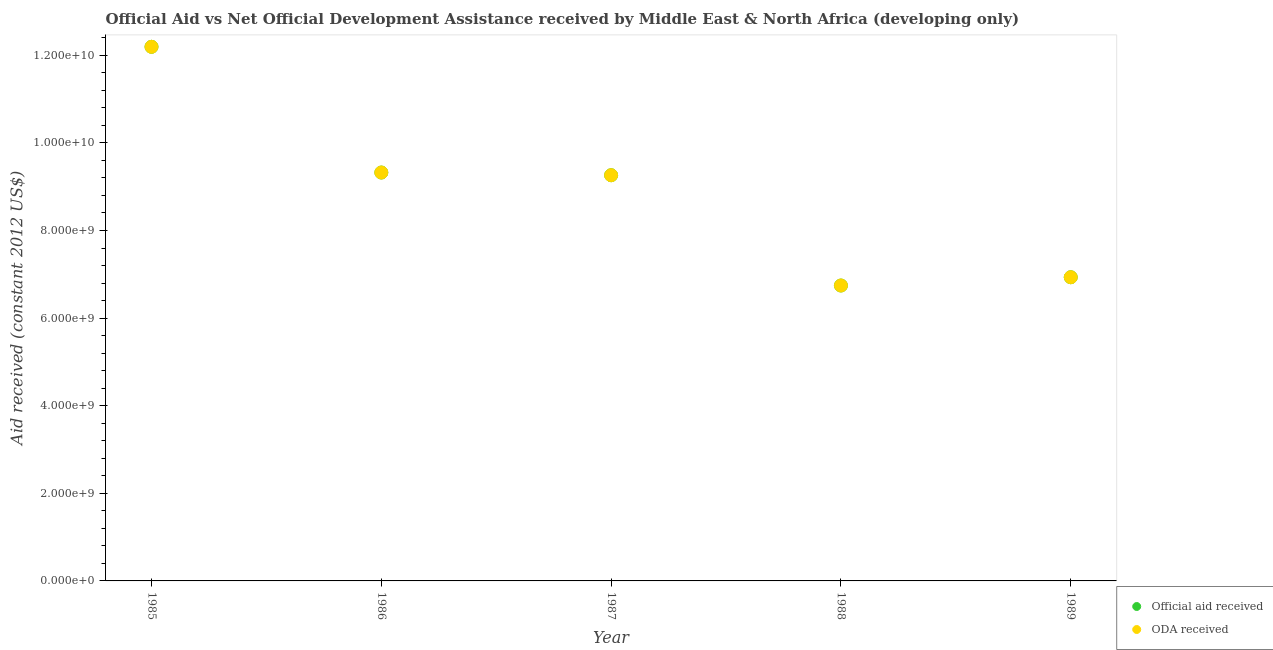How many different coloured dotlines are there?
Your answer should be compact. 2. Is the number of dotlines equal to the number of legend labels?
Your response must be concise. Yes. What is the oda received in 1987?
Your answer should be very brief. 9.26e+09. Across all years, what is the maximum oda received?
Offer a very short reply. 1.22e+1. Across all years, what is the minimum official aid received?
Offer a terse response. 6.74e+09. In which year was the official aid received maximum?
Give a very brief answer. 1985. What is the total oda received in the graph?
Offer a terse response. 4.45e+1. What is the difference between the oda received in 1986 and that in 1988?
Provide a short and direct response. 2.58e+09. What is the difference between the oda received in 1988 and the official aid received in 1986?
Ensure brevity in your answer.  -2.58e+09. What is the average oda received per year?
Keep it short and to the point. 8.89e+09. In the year 1988, what is the difference between the oda received and official aid received?
Your answer should be very brief. 0. In how many years, is the official aid received greater than 400000000 US$?
Give a very brief answer. 5. What is the ratio of the oda received in 1985 to that in 1987?
Ensure brevity in your answer.  1.32. What is the difference between the highest and the second highest oda received?
Provide a succinct answer. 2.87e+09. What is the difference between the highest and the lowest oda received?
Give a very brief answer. 5.45e+09. In how many years, is the official aid received greater than the average official aid received taken over all years?
Your answer should be compact. 3. Does the oda received monotonically increase over the years?
Make the answer very short. No. Is the oda received strictly less than the official aid received over the years?
Your answer should be very brief. No. How many dotlines are there?
Your response must be concise. 2. Are the values on the major ticks of Y-axis written in scientific E-notation?
Offer a very short reply. Yes. Where does the legend appear in the graph?
Your response must be concise. Bottom right. How are the legend labels stacked?
Give a very brief answer. Vertical. What is the title of the graph?
Ensure brevity in your answer.  Official Aid vs Net Official Development Assistance received by Middle East & North Africa (developing only) . Does "From production" appear as one of the legend labels in the graph?
Keep it short and to the point. No. What is the label or title of the X-axis?
Your answer should be compact. Year. What is the label or title of the Y-axis?
Your response must be concise. Aid received (constant 2012 US$). What is the Aid received (constant 2012 US$) in Official aid received in 1985?
Give a very brief answer. 1.22e+1. What is the Aid received (constant 2012 US$) in ODA received in 1985?
Provide a short and direct response. 1.22e+1. What is the Aid received (constant 2012 US$) in Official aid received in 1986?
Offer a terse response. 9.32e+09. What is the Aid received (constant 2012 US$) of ODA received in 1986?
Your answer should be compact. 9.32e+09. What is the Aid received (constant 2012 US$) in Official aid received in 1987?
Offer a terse response. 9.26e+09. What is the Aid received (constant 2012 US$) in ODA received in 1987?
Offer a terse response. 9.26e+09. What is the Aid received (constant 2012 US$) of Official aid received in 1988?
Provide a short and direct response. 6.74e+09. What is the Aid received (constant 2012 US$) of ODA received in 1988?
Give a very brief answer. 6.74e+09. What is the Aid received (constant 2012 US$) of Official aid received in 1989?
Provide a succinct answer. 6.93e+09. What is the Aid received (constant 2012 US$) in ODA received in 1989?
Make the answer very short. 6.93e+09. Across all years, what is the maximum Aid received (constant 2012 US$) in Official aid received?
Give a very brief answer. 1.22e+1. Across all years, what is the maximum Aid received (constant 2012 US$) of ODA received?
Give a very brief answer. 1.22e+1. Across all years, what is the minimum Aid received (constant 2012 US$) of Official aid received?
Ensure brevity in your answer.  6.74e+09. Across all years, what is the minimum Aid received (constant 2012 US$) of ODA received?
Your answer should be compact. 6.74e+09. What is the total Aid received (constant 2012 US$) in Official aid received in the graph?
Offer a terse response. 4.45e+1. What is the total Aid received (constant 2012 US$) of ODA received in the graph?
Keep it short and to the point. 4.45e+1. What is the difference between the Aid received (constant 2012 US$) of Official aid received in 1985 and that in 1986?
Offer a terse response. 2.87e+09. What is the difference between the Aid received (constant 2012 US$) of ODA received in 1985 and that in 1986?
Your answer should be very brief. 2.87e+09. What is the difference between the Aid received (constant 2012 US$) of Official aid received in 1985 and that in 1987?
Ensure brevity in your answer.  2.93e+09. What is the difference between the Aid received (constant 2012 US$) of ODA received in 1985 and that in 1987?
Your response must be concise. 2.93e+09. What is the difference between the Aid received (constant 2012 US$) of Official aid received in 1985 and that in 1988?
Ensure brevity in your answer.  5.45e+09. What is the difference between the Aid received (constant 2012 US$) in ODA received in 1985 and that in 1988?
Make the answer very short. 5.45e+09. What is the difference between the Aid received (constant 2012 US$) in Official aid received in 1985 and that in 1989?
Your answer should be compact. 5.26e+09. What is the difference between the Aid received (constant 2012 US$) in ODA received in 1985 and that in 1989?
Offer a terse response. 5.26e+09. What is the difference between the Aid received (constant 2012 US$) in Official aid received in 1986 and that in 1987?
Offer a terse response. 6.17e+07. What is the difference between the Aid received (constant 2012 US$) of ODA received in 1986 and that in 1987?
Provide a short and direct response. 6.17e+07. What is the difference between the Aid received (constant 2012 US$) in Official aid received in 1986 and that in 1988?
Provide a short and direct response. 2.58e+09. What is the difference between the Aid received (constant 2012 US$) of ODA received in 1986 and that in 1988?
Your response must be concise. 2.58e+09. What is the difference between the Aid received (constant 2012 US$) in Official aid received in 1986 and that in 1989?
Your response must be concise. 2.39e+09. What is the difference between the Aid received (constant 2012 US$) in ODA received in 1986 and that in 1989?
Keep it short and to the point. 2.39e+09. What is the difference between the Aid received (constant 2012 US$) of Official aid received in 1987 and that in 1988?
Keep it short and to the point. 2.52e+09. What is the difference between the Aid received (constant 2012 US$) of ODA received in 1987 and that in 1988?
Offer a terse response. 2.52e+09. What is the difference between the Aid received (constant 2012 US$) in Official aid received in 1987 and that in 1989?
Your answer should be compact. 2.33e+09. What is the difference between the Aid received (constant 2012 US$) of ODA received in 1987 and that in 1989?
Give a very brief answer. 2.33e+09. What is the difference between the Aid received (constant 2012 US$) in Official aid received in 1988 and that in 1989?
Make the answer very short. -1.89e+08. What is the difference between the Aid received (constant 2012 US$) in ODA received in 1988 and that in 1989?
Give a very brief answer. -1.89e+08. What is the difference between the Aid received (constant 2012 US$) of Official aid received in 1985 and the Aid received (constant 2012 US$) of ODA received in 1986?
Offer a very short reply. 2.87e+09. What is the difference between the Aid received (constant 2012 US$) in Official aid received in 1985 and the Aid received (constant 2012 US$) in ODA received in 1987?
Give a very brief answer. 2.93e+09. What is the difference between the Aid received (constant 2012 US$) of Official aid received in 1985 and the Aid received (constant 2012 US$) of ODA received in 1988?
Your answer should be very brief. 5.45e+09. What is the difference between the Aid received (constant 2012 US$) in Official aid received in 1985 and the Aid received (constant 2012 US$) in ODA received in 1989?
Provide a short and direct response. 5.26e+09. What is the difference between the Aid received (constant 2012 US$) of Official aid received in 1986 and the Aid received (constant 2012 US$) of ODA received in 1987?
Provide a succinct answer. 6.17e+07. What is the difference between the Aid received (constant 2012 US$) of Official aid received in 1986 and the Aid received (constant 2012 US$) of ODA received in 1988?
Make the answer very short. 2.58e+09. What is the difference between the Aid received (constant 2012 US$) of Official aid received in 1986 and the Aid received (constant 2012 US$) of ODA received in 1989?
Make the answer very short. 2.39e+09. What is the difference between the Aid received (constant 2012 US$) in Official aid received in 1987 and the Aid received (constant 2012 US$) in ODA received in 1988?
Ensure brevity in your answer.  2.52e+09. What is the difference between the Aid received (constant 2012 US$) of Official aid received in 1987 and the Aid received (constant 2012 US$) of ODA received in 1989?
Provide a short and direct response. 2.33e+09. What is the difference between the Aid received (constant 2012 US$) of Official aid received in 1988 and the Aid received (constant 2012 US$) of ODA received in 1989?
Offer a terse response. -1.89e+08. What is the average Aid received (constant 2012 US$) in Official aid received per year?
Your answer should be compact. 8.89e+09. What is the average Aid received (constant 2012 US$) of ODA received per year?
Make the answer very short. 8.89e+09. In the year 1986, what is the difference between the Aid received (constant 2012 US$) in Official aid received and Aid received (constant 2012 US$) in ODA received?
Provide a succinct answer. 0. In the year 1987, what is the difference between the Aid received (constant 2012 US$) of Official aid received and Aid received (constant 2012 US$) of ODA received?
Make the answer very short. 0. In the year 1988, what is the difference between the Aid received (constant 2012 US$) of Official aid received and Aid received (constant 2012 US$) of ODA received?
Keep it short and to the point. 0. What is the ratio of the Aid received (constant 2012 US$) in Official aid received in 1985 to that in 1986?
Provide a short and direct response. 1.31. What is the ratio of the Aid received (constant 2012 US$) in ODA received in 1985 to that in 1986?
Provide a succinct answer. 1.31. What is the ratio of the Aid received (constant 2012 US$) of Official aid received in 1985 to that in 1987?
Provide a succinct answer. 1.32. What is the ratio of the Aid received (constant 2012 US$) of ODA received in 1985 to that in 1987?
Offer a very short reply. 1.32. What is the ratio of the Aid received (constant 2012 US$) of Official aid received in 1985 to that in 1988?
Your answer should be very brief. 1.81. What is the ratio of the Aid received (constant 2012 US$) of ODA received in 1985 to that in 1988?
Your answer should be very brief. 1.81. What is the ratio of the Aid received (constant 2012 US$) of Official aid received in 1985 to that in 1989?
Offer a very short reply. 1.76. What is the ratio of the Aid received (constant 2012 US$) of ODA received in 1985 to that in 1989?
Make the answer very short. 1.76. What is the ratio of the Aid received (constant 2012 US$) in ODA received in 1986 to that in 1987?
Offer a very short reply. 1.01. What is the ratio of the Aid received (constant 2012 US$) of Official aid received in 1986 to that in 1988?
Provide a short and direct response. 1.38. What is the ratio of the Aid received (constant 2012 US$) in ODA received in 1986 to that in 1988?
Your answer should be very brief. 1.38. What is the ratio of the Aid received (constant 2012 US$) in Official aid received in 1986 to that in 1989?
Your answer should be compact. 1.34. What is the ratio of the Aid received (constant 2012 US$) in ODA received in 1986 to that in 1989?
Your answer should be compact. 1.34. What is the ratio of the Aid received (constant 2012 US$) of Official aid received in 1987 to that in 1988?
Ensure brevity in your answer.  1.37. What is the ratio of the Aid received (constant 2012 US$) in ODA received in 1987 to that in 1988?
Keep it short and to the point. 1.37. What is the ratio of the Aid received (constant 2012 US$) of Official aid received in 1987 to that in 1989?
Ensure brevity in your answer.  1.34. What is the ratio of the Aid received (constant 2012 US$) in ODA received in 1987 to that in 1989?
Provide a succinct answer. 1.34. What is the ratio of the Aid received (constant 2012 US$) of Official aid received in 1988 to that in 1989?
Your answer should be very brief. 0.97. What is the ratio of the Aid received (constant 2012 US$) in ODA received in 1988 to that in 1989?
Provide a short and direct response. 0.97. What is the difference between the highest and the second highest Aid received (constant 2012 US$) in Official aid received?
Your response must be concise. 2.87e+09. What is the difference between the highest and the second highest Aid received (constant 2012 US$) in ODA received?
Your response must be concise. 2.87e+09. What is the difference between the highest and the lowest Aid received (constant 2012 US$) in Official aid received?
Your response must be concise. 5.45e+09. What is the difference between the highest and the lowest Aid received (constant 2012 US$) of ODA received?
Your answer should be very brief. 5.45e+09. 